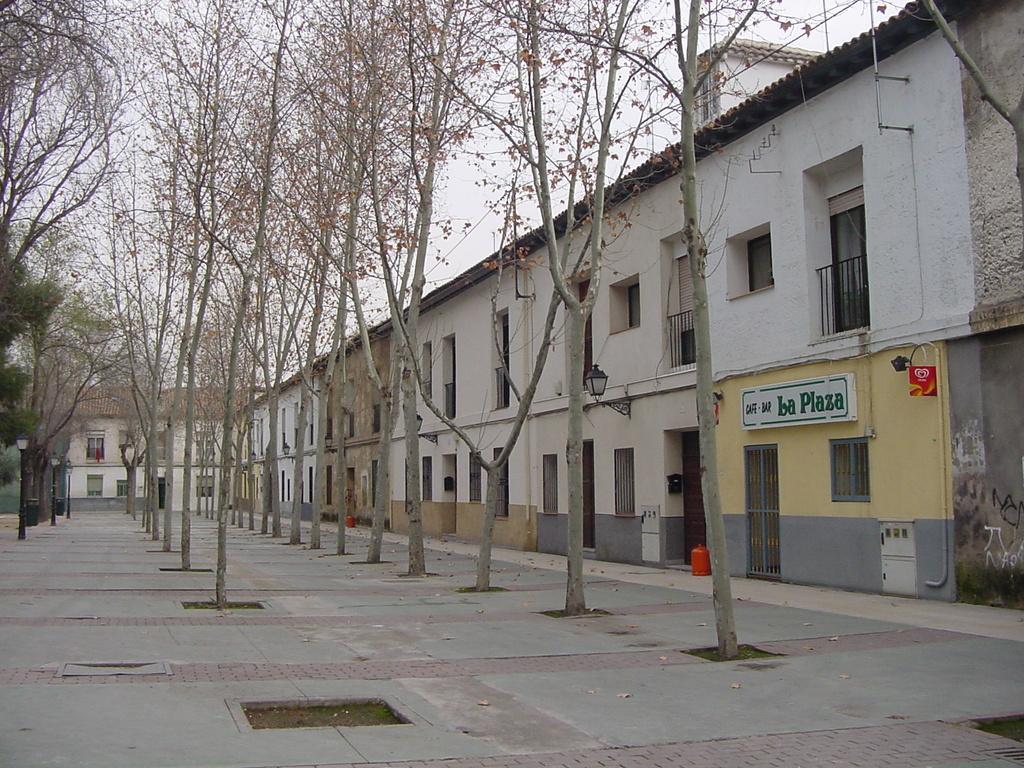Describe this image in one or two sentences. In the image there is a wide building, it has many doors and windows and in front of that building there are tall trees in between the path. 